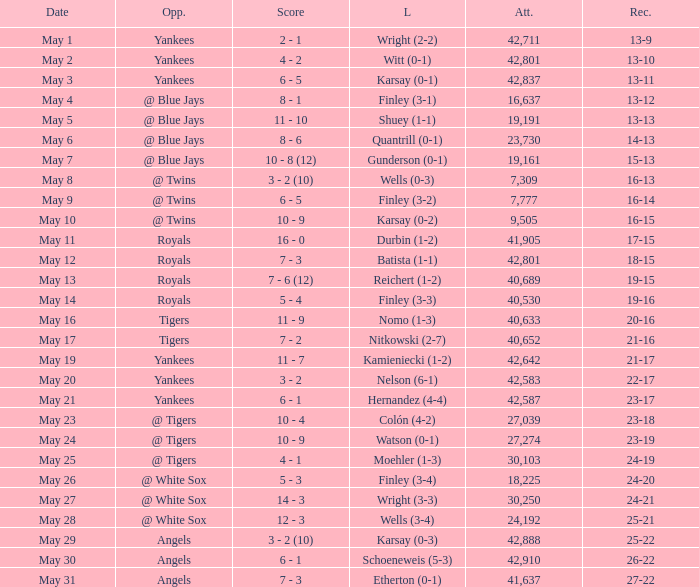What is the attendance for the game on May 25? 30103.0. 